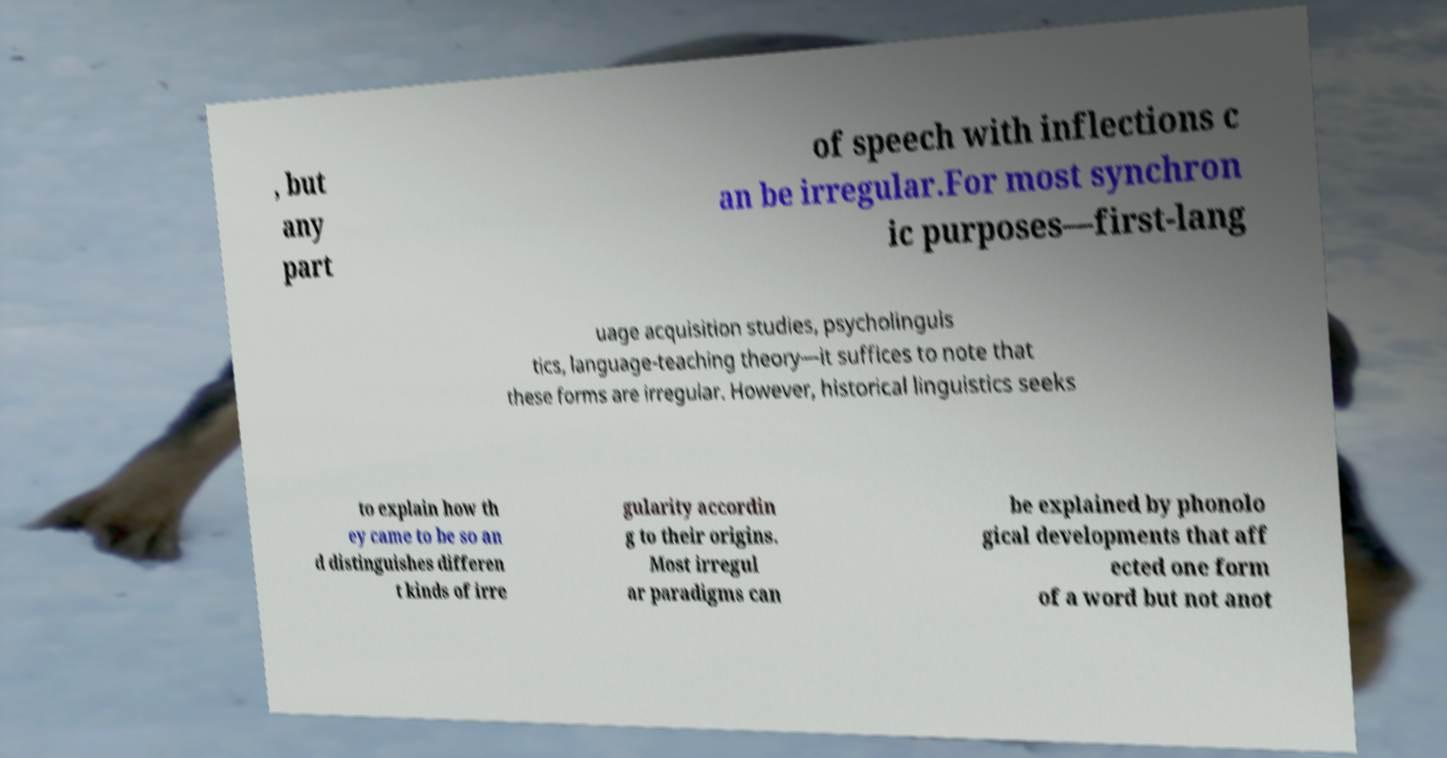Can you read and provide the text displayed in the image?This photo seems to have some interesting text. Can you extract and type it out for me? , but any part of speech with inflections c an be irregular.For most synchron ic purposes—first-lang uage acquisition studies, psycholinguis tics, language-teaching theory—it suffices to note that these forms are irregular. However, historical linguistics seeks to explain how th ey came to be so an d distinguishes differen t kinds of irre gularity accordin g to their origins. Most irregul ar paradigms can be explained by phonolo gical developments that aff ected one form of a word but not anot 